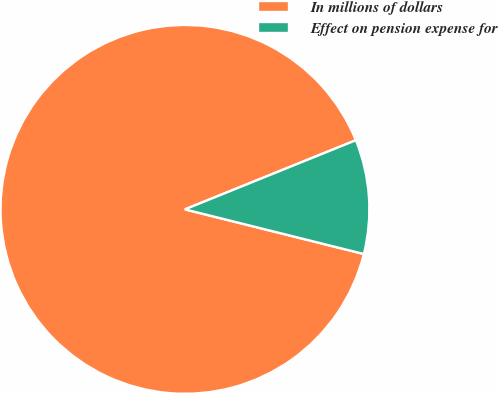Convert chart to OTSL. <chart><loc_0><loc_0><loc_500><loc_500><pie_chart><fcel>In millions of dollars<fcel>Effect on pension expense for<nl><fcel>89.99%<fcel>10.01%<nl></chart> 